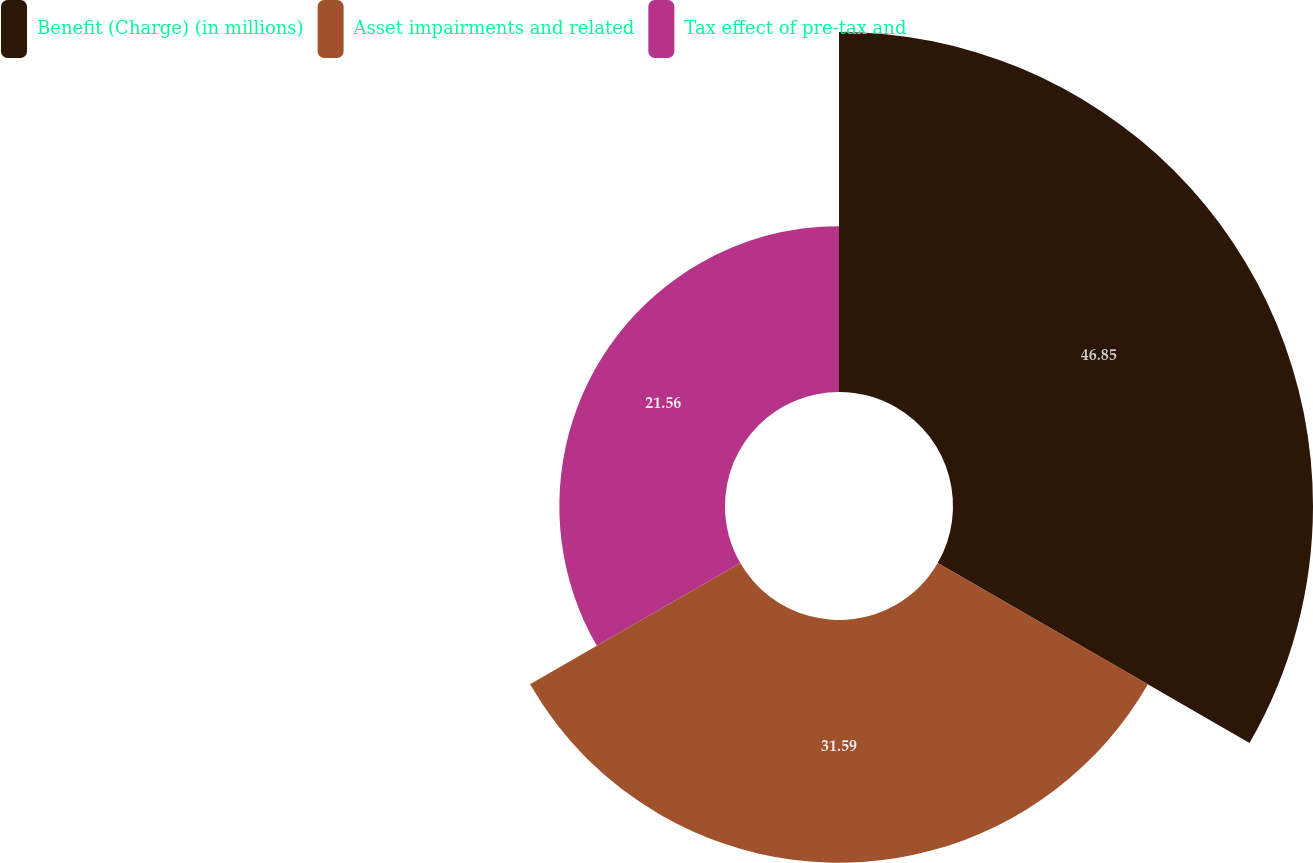Convert chart to OTSL. <chart><loc_0><loc_0><loc_500><loc_500><pie_chart><fcel>Benefit (Charge) (in millions)<fcel>Asset impairments and related<fcel>Tax effect of pre-tax and<nl><fcel>46.85%<fcel>31.59%<fcel>21.56%<nl></chart> 